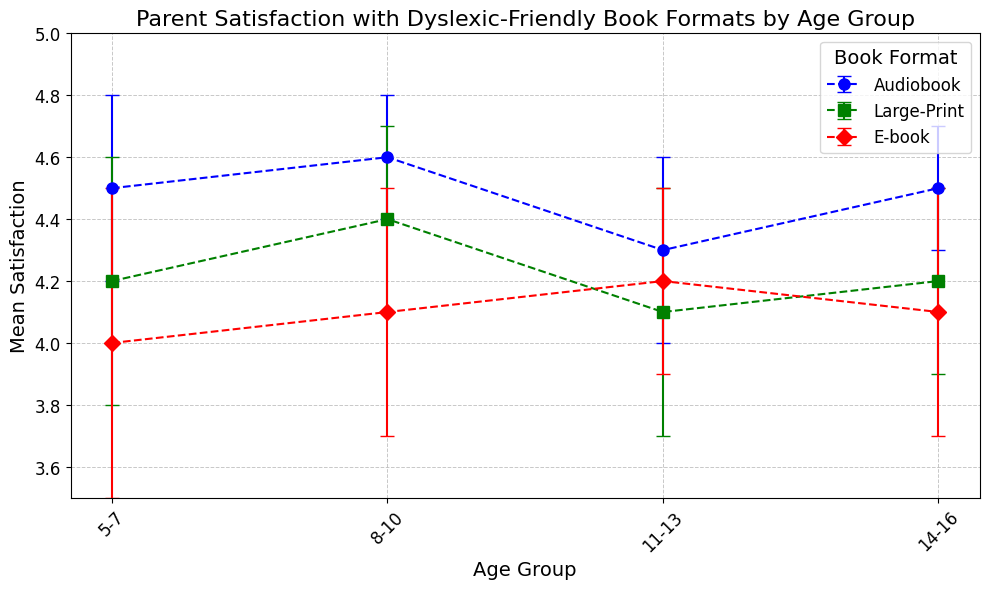What's the highest mean satisfaction score for any book format across all age groups? The highest mean satisfaction score can be found by looking at the peaks of the error bars for each group across all age formats. The highest mean satisfaction score is for audiobooks in the 8-10 age group, with a score of 4.6.
Answer: 4.6 Which book format shows the most consistent satisfaction scores across all age groups, considering the error bars? Consistency can be assessed by looking at how tightly the error bars are clustered across age groups. Audiobooks have the smallest error bars consistently across all age groups, indicating more consistent satisfaction scores.
Answer: Audiobooks How does the mean satisfaction for large-print books for the 8-10 age group compare to the mean satisfaction for e-books for the same age group? Compare the mean satisfaction values directly from the chart for the 8-10 age group. For large-print, the mean satisfaction is 4.4, while for e-books it's 4.1. 4.4 > 4.1, so large-print books have higher satisfaction.
Answer: 4.4 > 4.1 What's the overall trend of mean satisfaction scores for audiobooks as the age group increases? The mean satisfaction scores for audiobooks for each age group are as follows: 5-7 (4.5), 8-10 (4.6), 11-13 (4.3), and 14-16 (4.5). The trend shows that satisfaction is fairly high and stable, with a slight dip in the 11-13 age group.
Answer: Stable with a slight dip in 11-13 Which age group has the lowest mean satisfaction score for any format, and what is that score? Identify the lowest mean satisfaction score for any book format across all age groups. The lowest score is for e-books in the 14-16 age group, with a mean satisfaction score of 4.1.
Answer: 14-16, 4.1 Compare the mean satisfaction score of large-print books for the 5-7 age group to the mean satisfaction score of e-books for the 11-13 age group. For the 5-7 age group, large-print books have a mean satisfaction score of 4.2. For the 11-13 age group, e-books have a mean satisfaction score of 4.2. The scores are the same.
Answer: 4.2 = 4.2 Which book format shows the largest error bar in the 5-7 age group? By examining the error bars for each format in the 5-7 age group, the e-book format has the largest error bar, with a value of 0.5.
Answer: E-books For which book format and age group combination do parents report the lowest satisfaction? Scan through the mean satisfaction scores to find the lowest value across formats and age groups. The lowest score is 4.0 for e-books in the 5-7 age group.
Answer: E-books, 5-7 